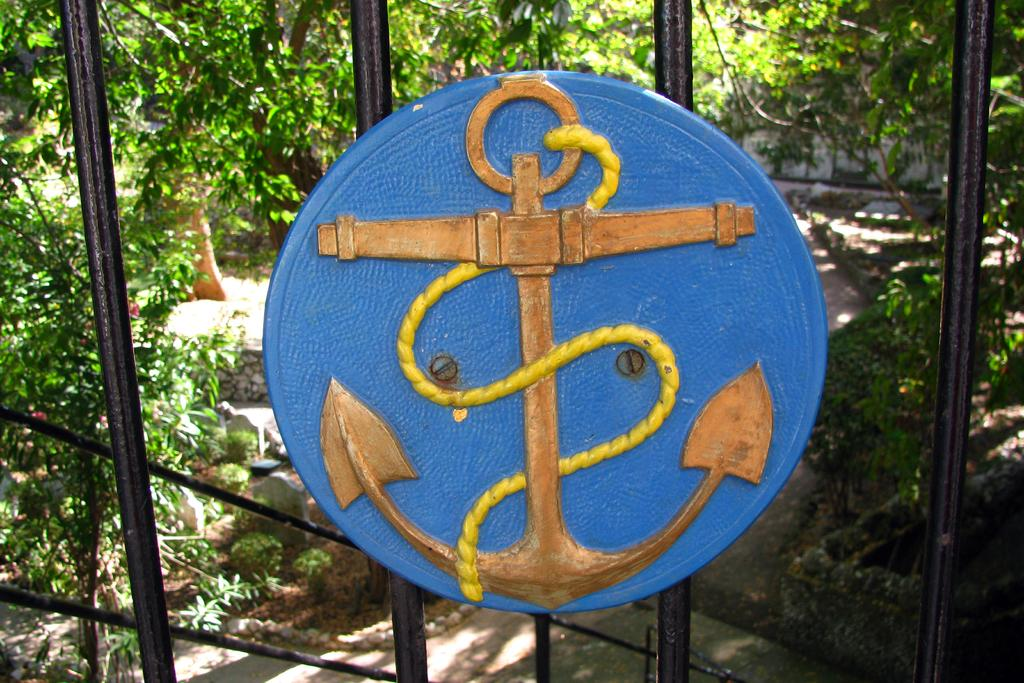What object is present in the image that is attached to something else? There is a board in the image that is attached to a railing. What is the color of the board in the image? The board is blue in color. What can be seen in the background of the image? There are plants in the background of the image. What is the color of the plants in the image? The plants are green in color. Where is the oven located in the image? There is no oven present in the image. What type of pail can be seen in the image? There is no pail present in the image. 